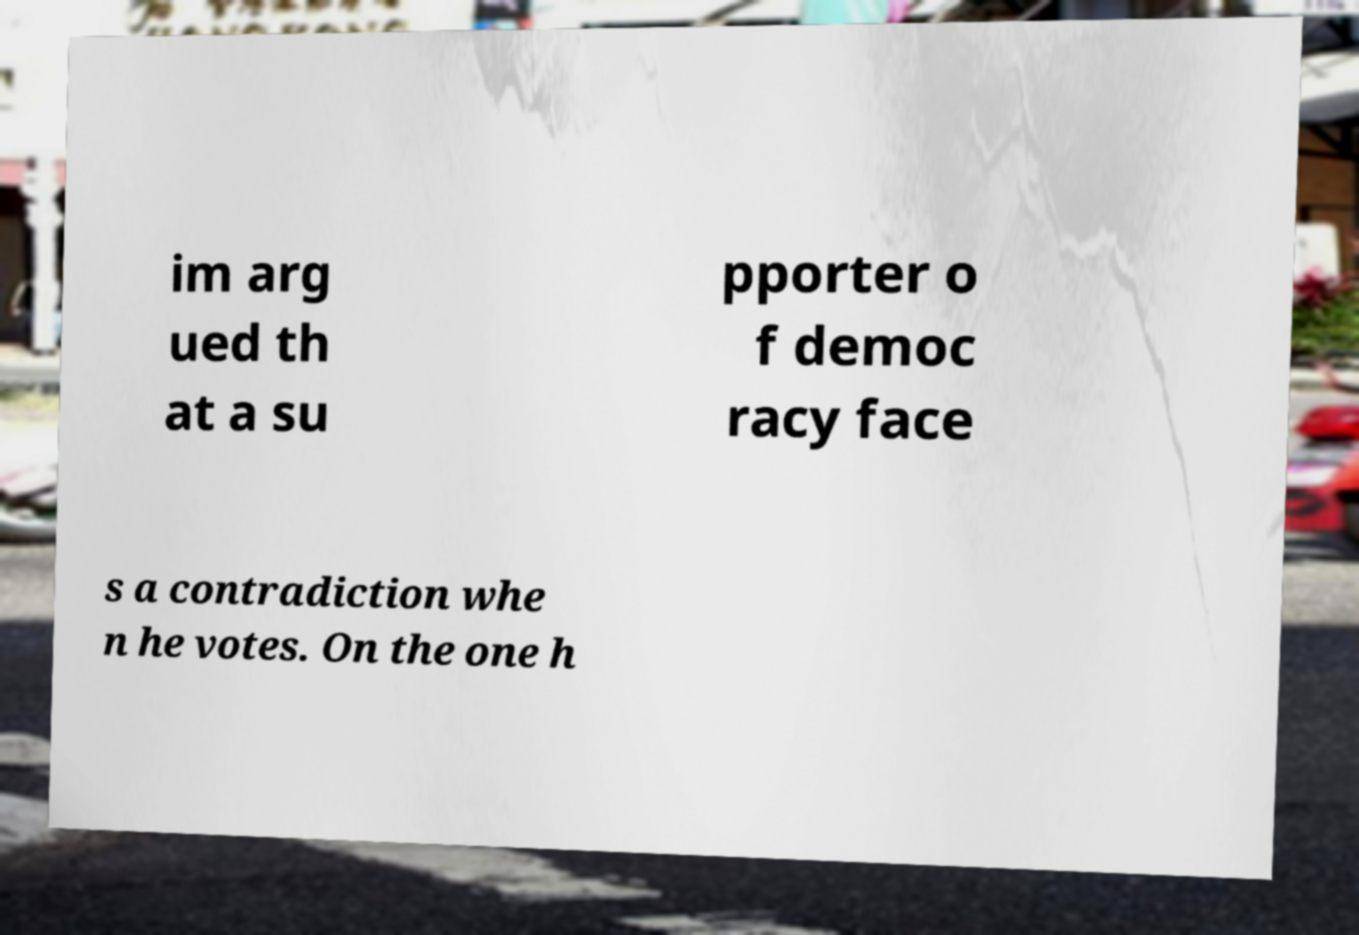Please identify and transcribe the text found in this image. im arg ued th at a su pporter o f democ racy face s a contradiction whe n he votes. On the one h 